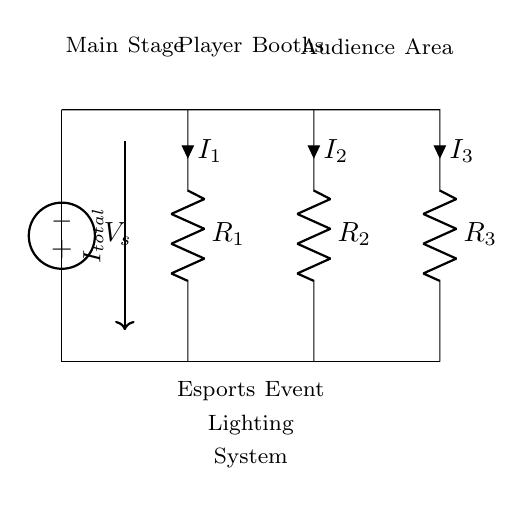What is the total current entering the circuit? The total current entering the circuit is represented as I total, which is indicated in the diagram at the first node where the voltage source connects to the resistors.
Answer: I total How many resistors are there in the circuit? The circuit diagram shows a total of three resistors (R1, R2, and R3) connected in parallel, as indicated by their symbols and connection points in the diagram.
Answer: 3 What does R1 represent? R1 represents one of the resistors in the current divider circuit, and it is the first resistor connected in parallel to the voltage source.
Answer: One of the resistors Which area corresponds to the player booths? The section labeled "Player Booths" is indicated between the nodes corresponding to the second resistor R2 in the circuit, as shown in the diagram.
Answer: Player Booths If the resistances are R1, R2, and R3, what is the formula for calculating I2? I2 can be calculated using the current divider rule, which states that I2 = I total * (R1 / (R1 + R2 + R3)). This involves the total current and the resistances of R1, R2, and R3 in the circuit.
Answer: I total * (R1 / (R1 + R2 + R3)) What is the role of the voltage source in this circuit? The voltage source provides the potential difference required to drive the current through the circuit, affecting how the current is divided among the parallel resistors.
Answer: Provides potential difference 